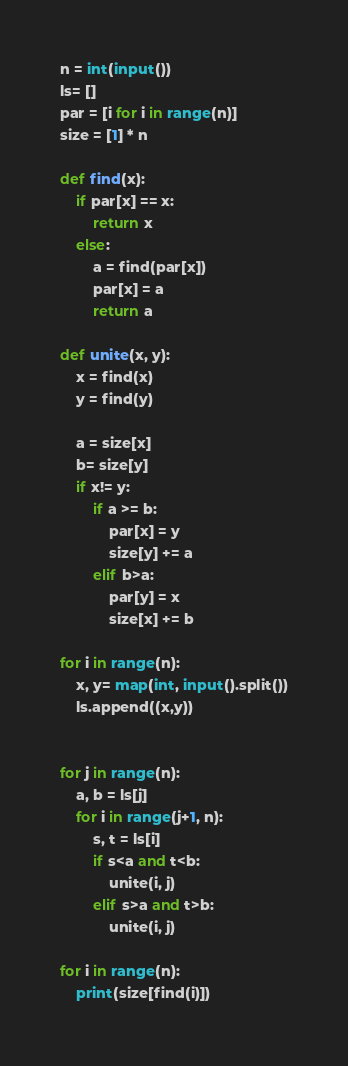Convert code to text. <code><loc_0><loc_0><loc_500><loc_500><_Python_>n = int(input())
ls= []
par = [i for i in range(n)]
size = [1] * n

def find(x):
    if par[x] == x:
        return x
    else:
        a = find(par[x])
        par[x] = a
        return a

def unite(x, y):
    x = find(x)
    y = find(y)

    a = size[x]
    b= size[y]
    if x!= y:
        if a >= b:
            par[x] = y
            size[y] += a
        elif b>a:
            par[y] = x
            size[x] += b

for i in range(n):
    x, y= map(int, input().split())
    ls.append((x,y))


for j in range(n):
    a, b = ls[j]
    for i in range(j+1, n):
        s, t = ls[i]
        if s<a and t<b:
            unite(i, j)
        elif s>a and t>b:
            unite(i, j)

for i in range(n):
    print(size[find(i)])</code> 